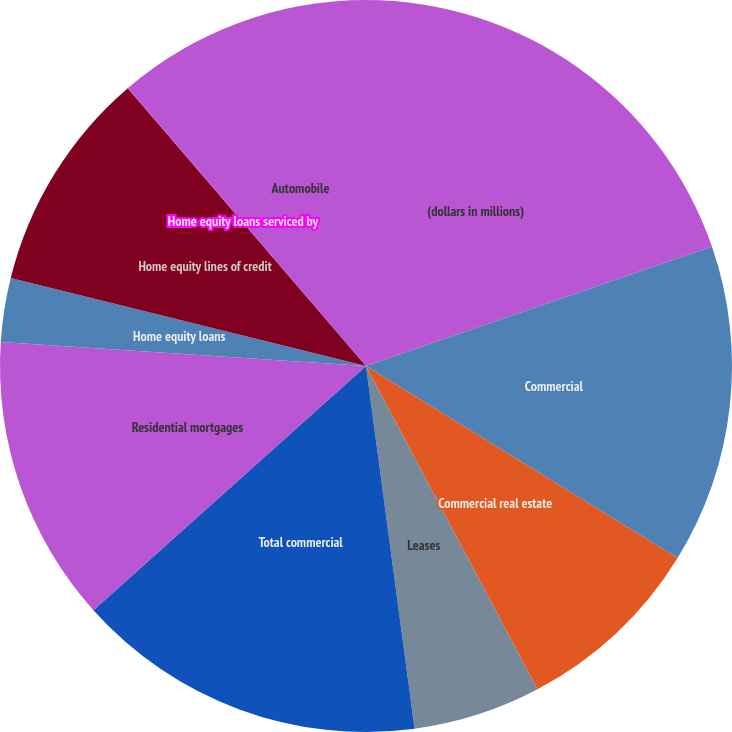Convert chart. <chart><loc_0><loc_0><loc_500><loc_500><pie_chart><fcel>(dollars in millions)<fcel>Commercial<fcel>Commercial real estate<fcel>Leases<fcel>Total commercial<fcel>Residential mortgages<fcel>Home equity loans<fcel>Home equity lines of credit<fcel>Home equity loans serviced by<fcel>Automobile<nl><fcel>19.71%<fcel>14.08%<fcel>8.45%<fcel>5.64%<fcel>15.49%<fcel>12.67%<fcel>2.82%<fcel>9.86%<fcel>0.01%<fcel>11.27%<nl></chart> 